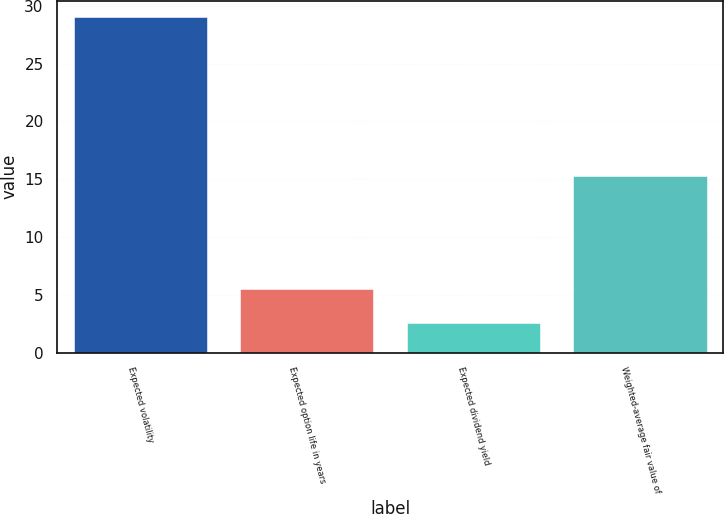<chart> <loc_0><loc_0><loc_500><loc_500><bar_chart><fcel>Expected volatility<fcel>Expected option life in years<fcel>Expected dividend yield<fcel>Weighted-average fair value of<nl><fcel>29<fcel>5.5<fcel>2.6<fcel>15.25<nl></chart> 